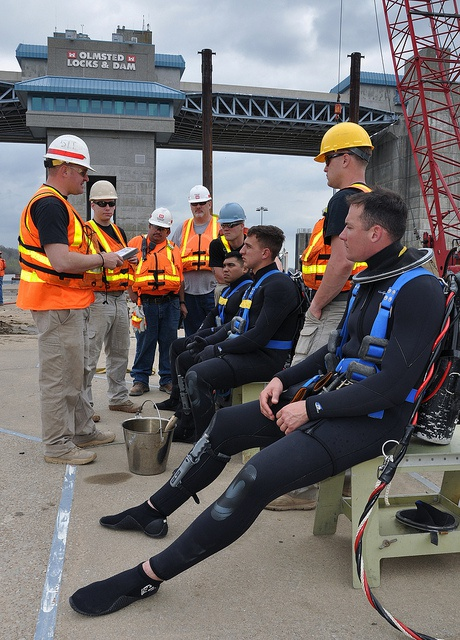Describe the objects in this image and their specific colors. I can see people in lightgray, black, gray, and darkgray tones, people in lightgray, gray, red, and black tones, bench in lightgray, darkgray, gray, and black tones, people in lightgray, black, navy, gray, and brown tones, and people in lightgray, black, brown, gray, and darkgray tones in this image. 